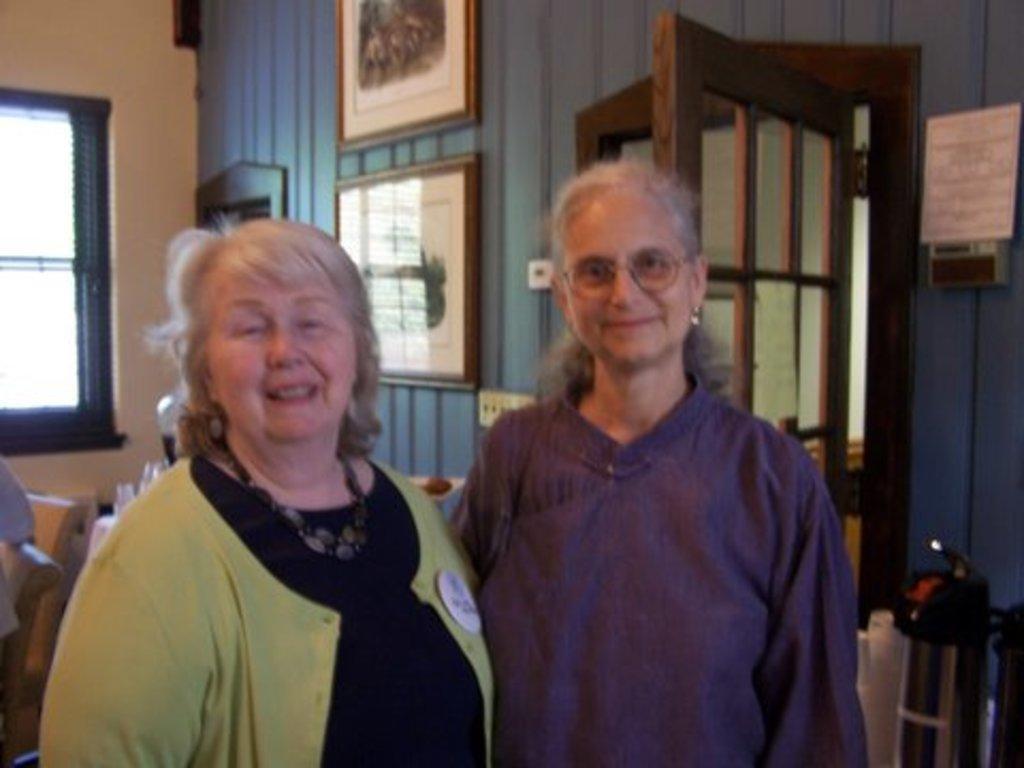Please provide a concise description of this image. In this image, I can see two women standing and smiling. Behind the women, there are photo frames attached to the wall and a door. On the left side of the image, I can see a window. At the bottom right side of the image, there is an object. 